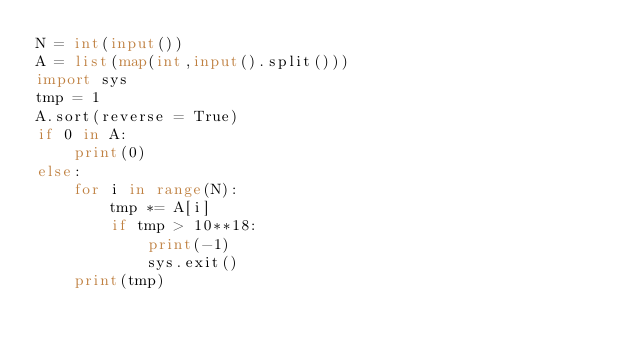<code> <loc_0><loc_0><loc_500><loc_500><_Python_>N = int(input())
A = list(map(int,input().split()))
import sys
tmp = 1
A.sort(reverse = True)
if 0 in A:
    print(0)
else:
    for i in range(N):
        tmp *= A[i]
        if tmp > 10**18:
            print(-1)
            sys.exit()
    print(tmp)</code> 